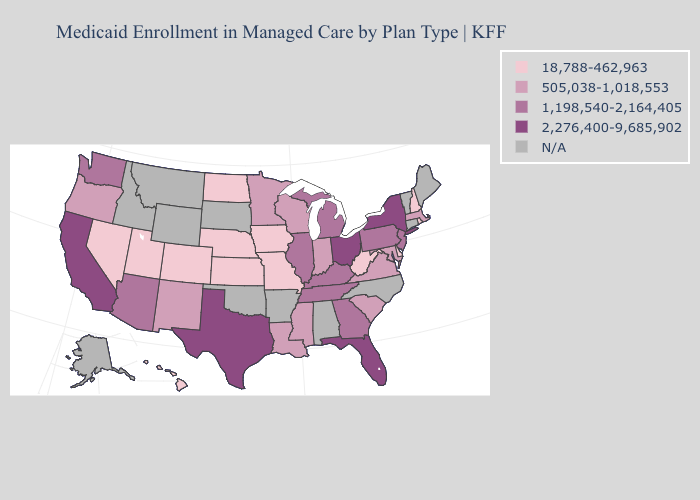Does Michigan have the lowest value in the USA?
Answer briefly. No. Name the states that have a value in the range 2,276,400-9,685,902?
Give a very brief answer. California, Florida, New York, Ohio, Texas. Does New Mexico have the lowest value in the USA?
Give a very brief answer. No. What is the value of Arkansas?
Answer briefly. N/A. What is the lowest value in the Northeast?
Give a very brief answer. 18,788-462,963. Name the states that have a value in the range 505,038-1,018,553?
Answer briefly. Indiana, Louisiana, Maryland, Massachusetts, Minnesota, Mississippi, New Mexico, Oregon, South Carolina, Virginia, Wisconsin. Name the states that have a value in the range 1,198,540-2,164,405?
Give a very brief answer. Arizona, Georgia, Illinois, Kentucky, Michigan, New Jersey, Pennsylvania, Tennessee, Washington. What is the lowest value in the USA?
Write a very short answer. 18,788-462,963. Name the states that have a value in the range N/A?
Concise answer only. Alabama, Alaska, Arkansas, Connecticut, Idaho, Maine, Montana, North Carolina, Oklahoma, South Dakota, Vermont, Wyoming. Which states have the lowest value in the USA?
Short answer required. Colorado, Delaware, Hawaii, Iowa, Kansas, Missouri, Nebraska, Nevada, New Hampshire, North Dakota, Rhode Island, Utah, West Virginia. Does North Dakota have the lowest value in the USA?
Keep it brief. Yes. Name the states that have a value in the range 505,038-1,018,553?
Concise answer only. Indiana, Louisiana, Maryland, Massachusetts, Minnesota, Mississippi, New Mexico, Oregon, South Carolina, Virginia, Wisconsin. What is the value of Oregon?
Answer briefly. 505,038-1,018,553. Is the legend a continuous bar?
Answer briefly. No. 